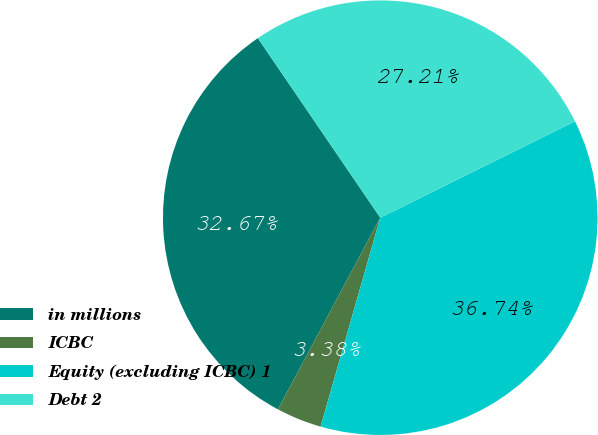<chart> <loc_0><loc_0><loc_500><loc_500><pie_chart><fcel>in millions<fcel>ICBC<fcel>Equity (excluding ICBC) 1<fcel>Debt 2<nl><fcel>32.67%<fcel>3.38%<fcel>36.74%<fcel>27.21%<nl></chart> 